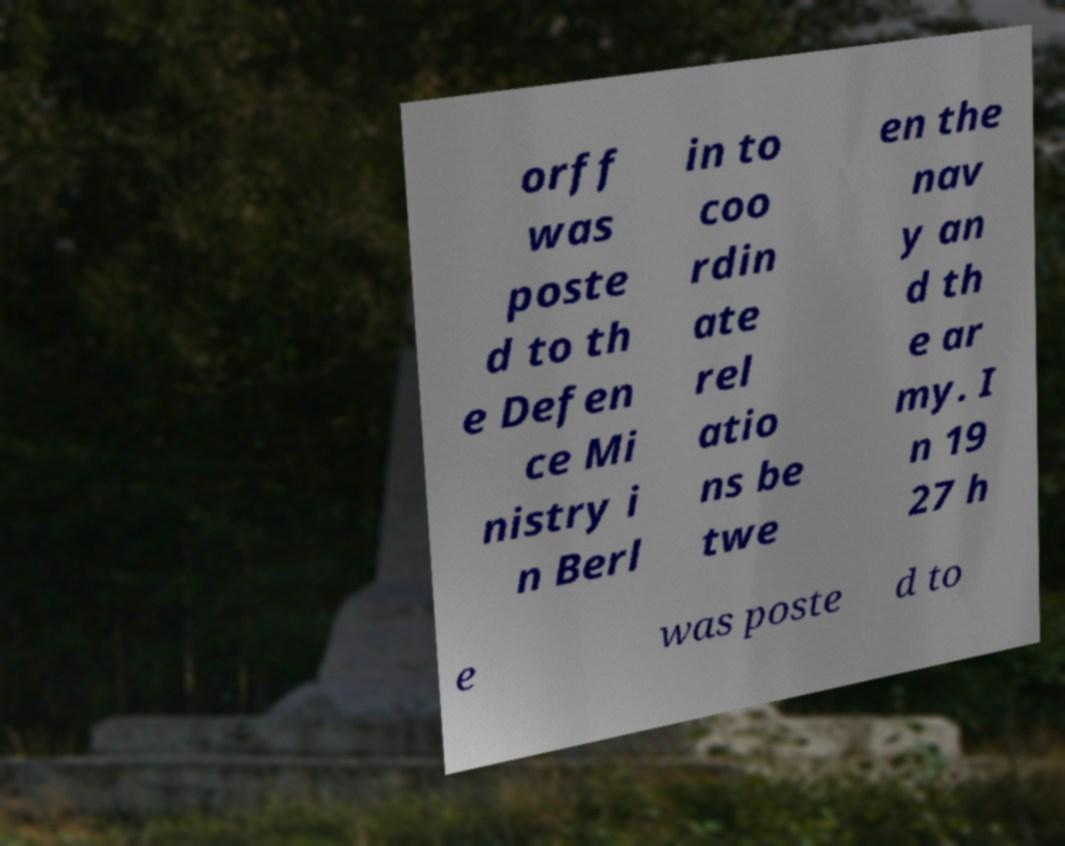Please read and relay the text visible in this image. What does it say? orff was poste d to th e Defen ce Mi nistry i n Berl in to coo rdin ate rel atio ns be twe en the nav y an d th e ar my. I n 19 27 h e was poste d to 